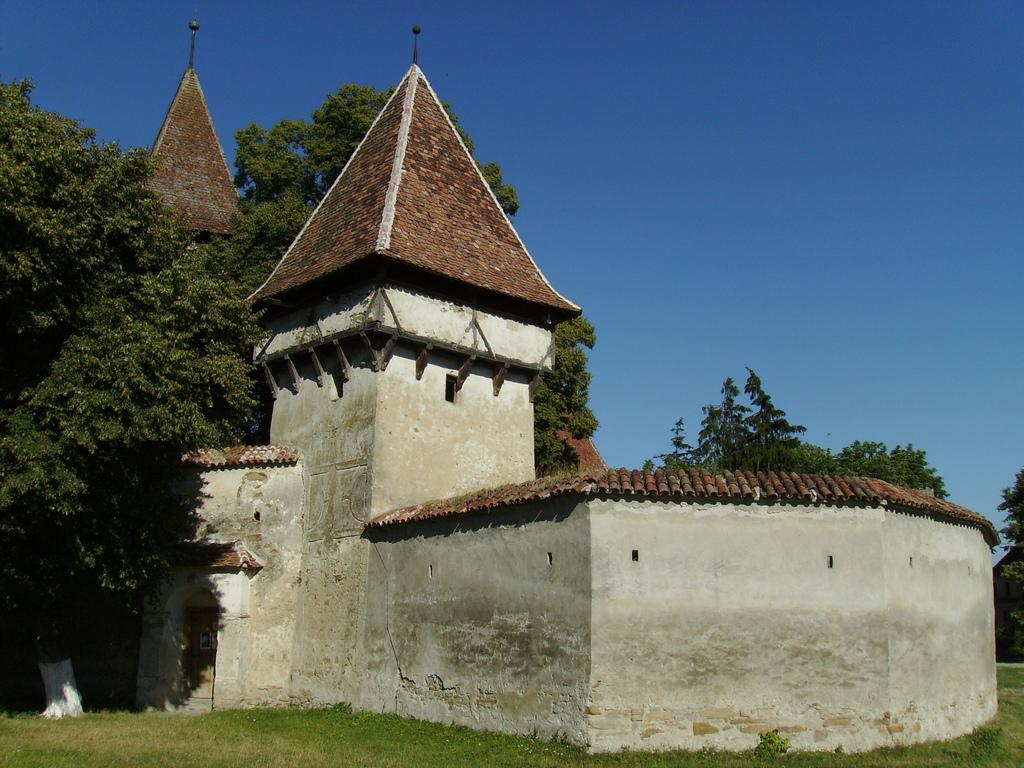What type of vegetation is present at the bottom of the image? There is grass on the ground at the bottom of the image. What can be seen in the background of the image? There are trees and buildings in the background of the image. What is the color of the sky in the image? The sky in the image is blue, with clouds visible. What type of connection can be seen between the grass and the clouds in the image? There is no connection between the grass and the clouds in the image; they are separate elements in the scene. 